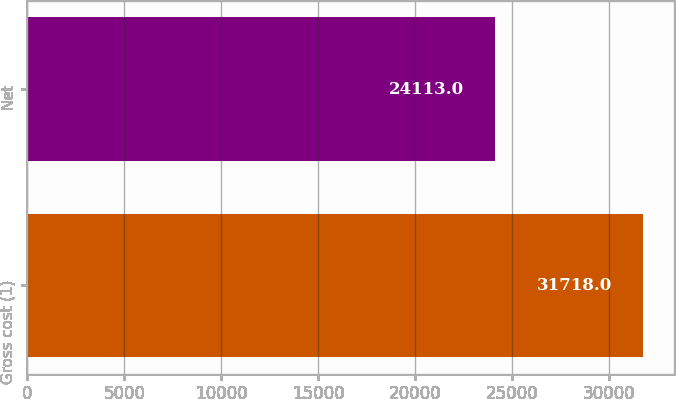Convert chart to OTSL. <chart><loc_0><loc_0><loc_500><loc_500><bar_chart><fcel>Gross cost (1)<fcel>Net<nl><fcel>31718<fcel>24113<nl></chart> 